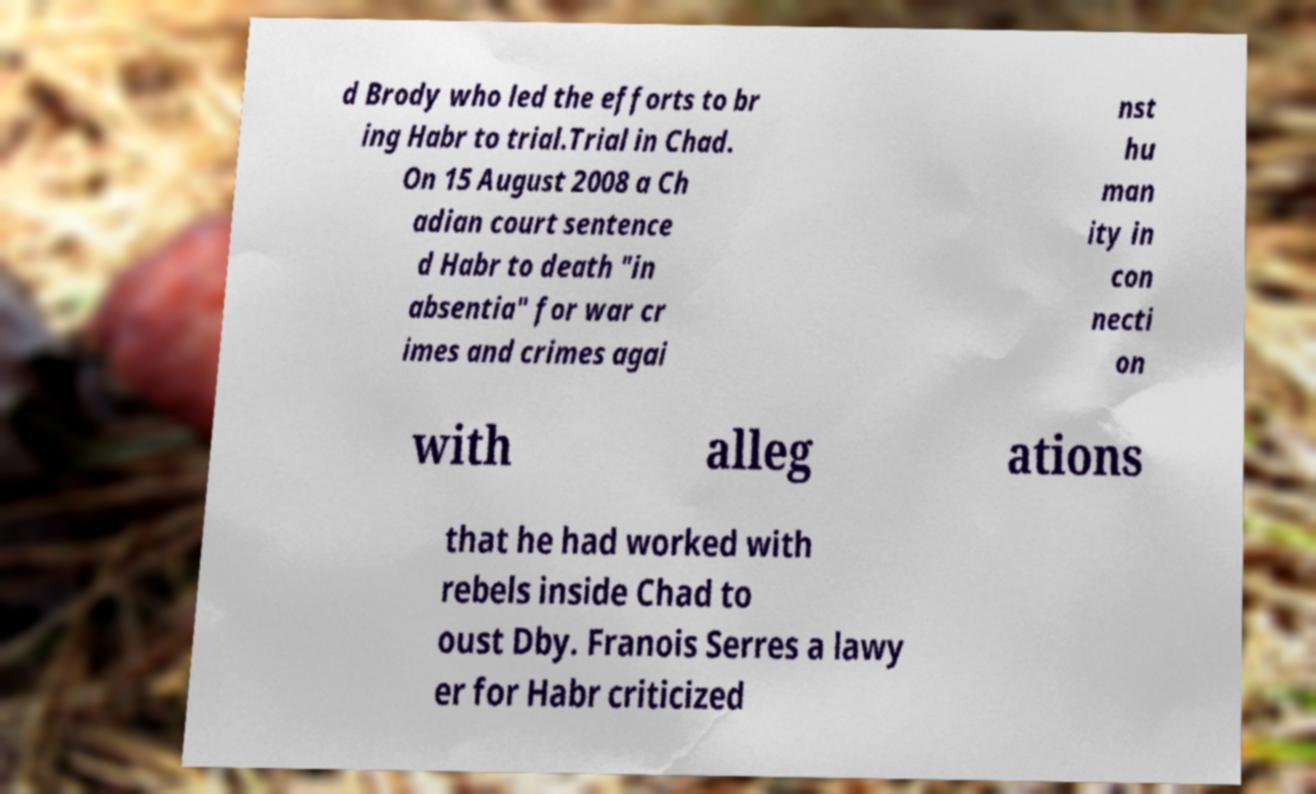For documentation purposes, I need the text within this image transcribed. Could you provide that? d Brody who led the efforts to br ing Habr to trial.Trial in Chad. On 15 August 2008 a Ch adian court sentence d Habr to death "in absentia" for war cr imes and crimes agai nst hu man ity in con necti on with alleg ations that he had worked with rebels inside Chad to oust Dby. Franois Serres a lawy er for Habr criticized 